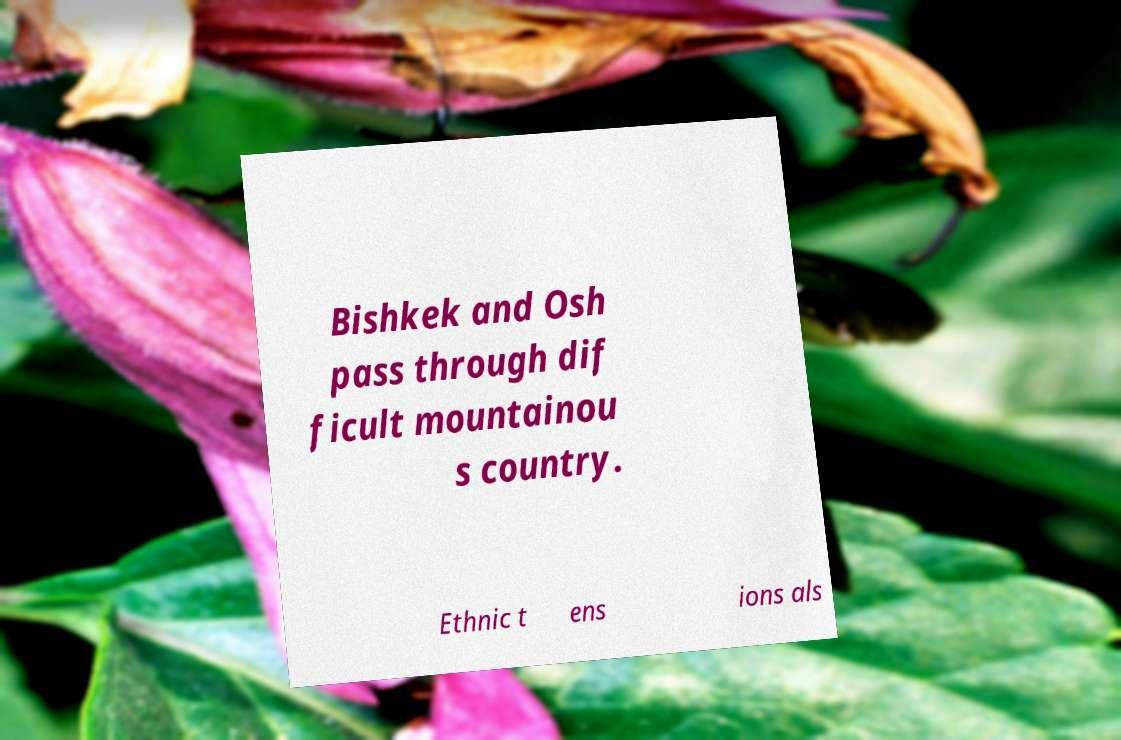I need the written content from this picture converted into text. Can you do that? Bishkek and Osh pass through dif ficult mountainou s country. Ethnic t ens ions als 